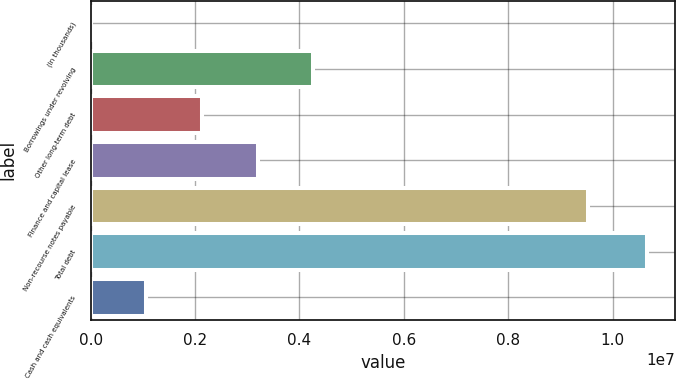<chart> <loc_0><loc_0><loc_500><loc_500><bar_chart><fcel>(In thousands)<fcel>Borrowings under revolving<fcel>Other long-term debt<fcel>Finance and capital lease<fcel>Non-recourse notes payable<fcel>Total debt<fcel>Cash and cash equivalents<nl><fcel>2016<fcel>4.26434e+06<fcel>2.13318e+06<fcel>3.19876e+06<fcel>9.52775e+06<fcel>1.06578e+07<fcel>1.0676e+06<nl></chart> 